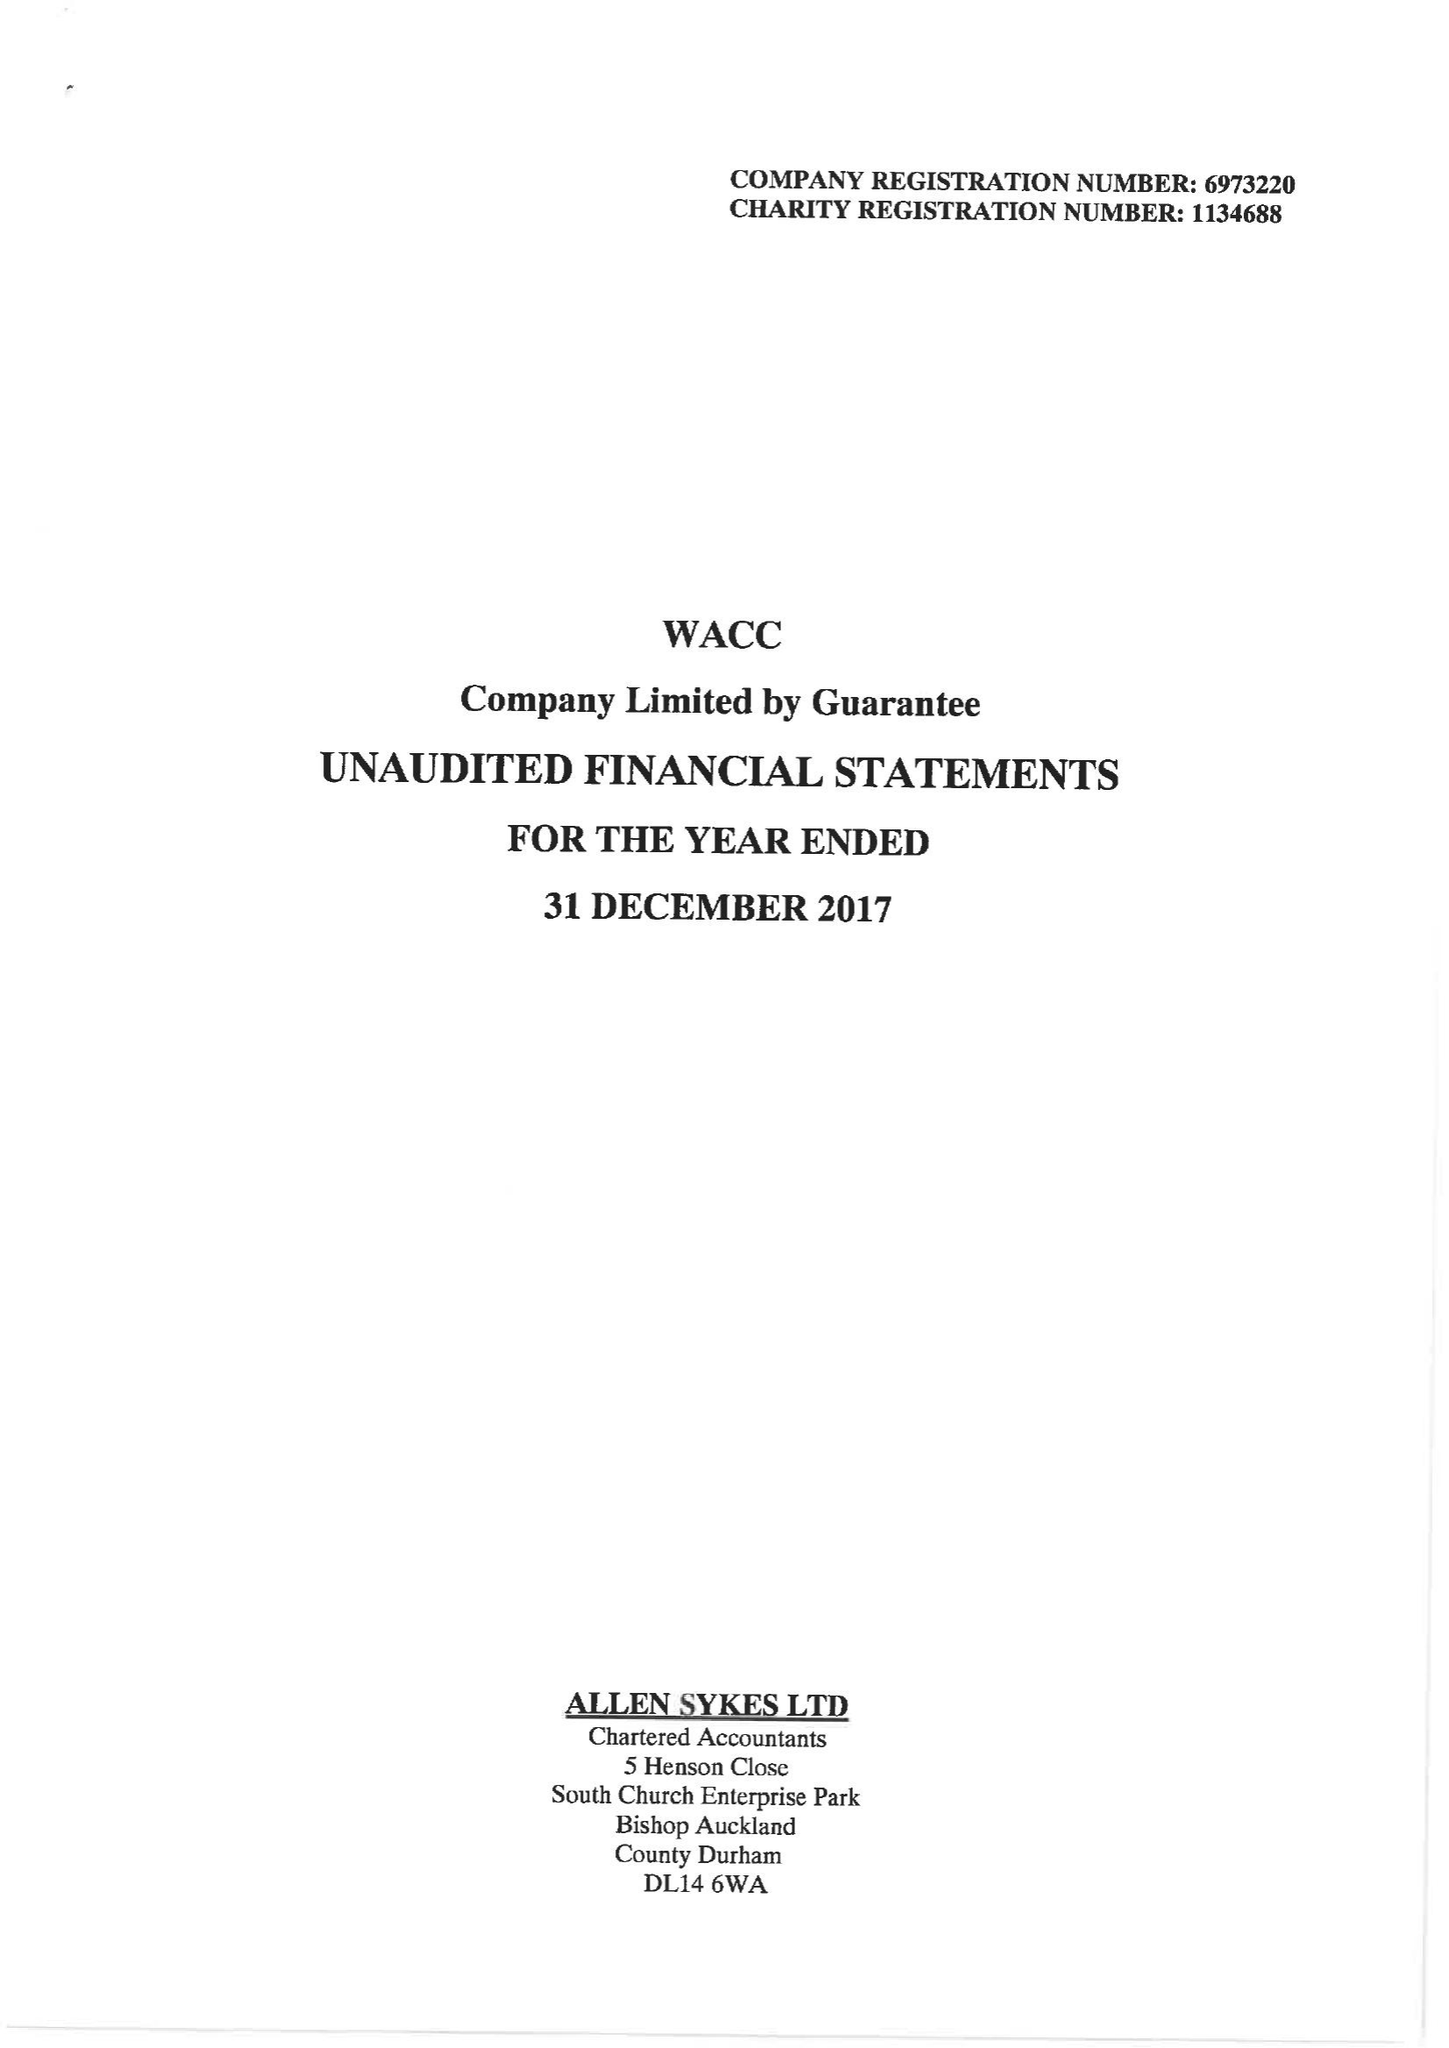What is the value for the spending_annually_in_british_pounds?
Answer the question using a single word or phrase. 75826.00 